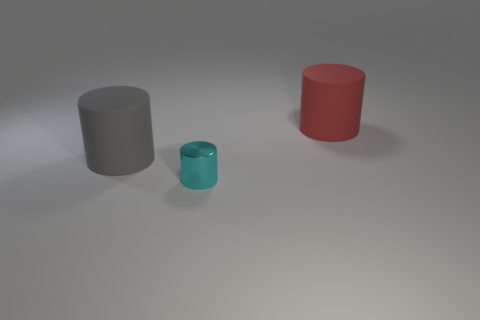Add 3 large yellow cylinders. How many objects exist? 6 Add 1 small green things. How many small green things exist? 1 Subtract 0 blue cylinders. How many objects are left? 3 Subtract all small cyan cylinders. Subtract all cyan objects. How many objects are left? 1 Add 2 small metallic things. How many small metallic things are left? 3 